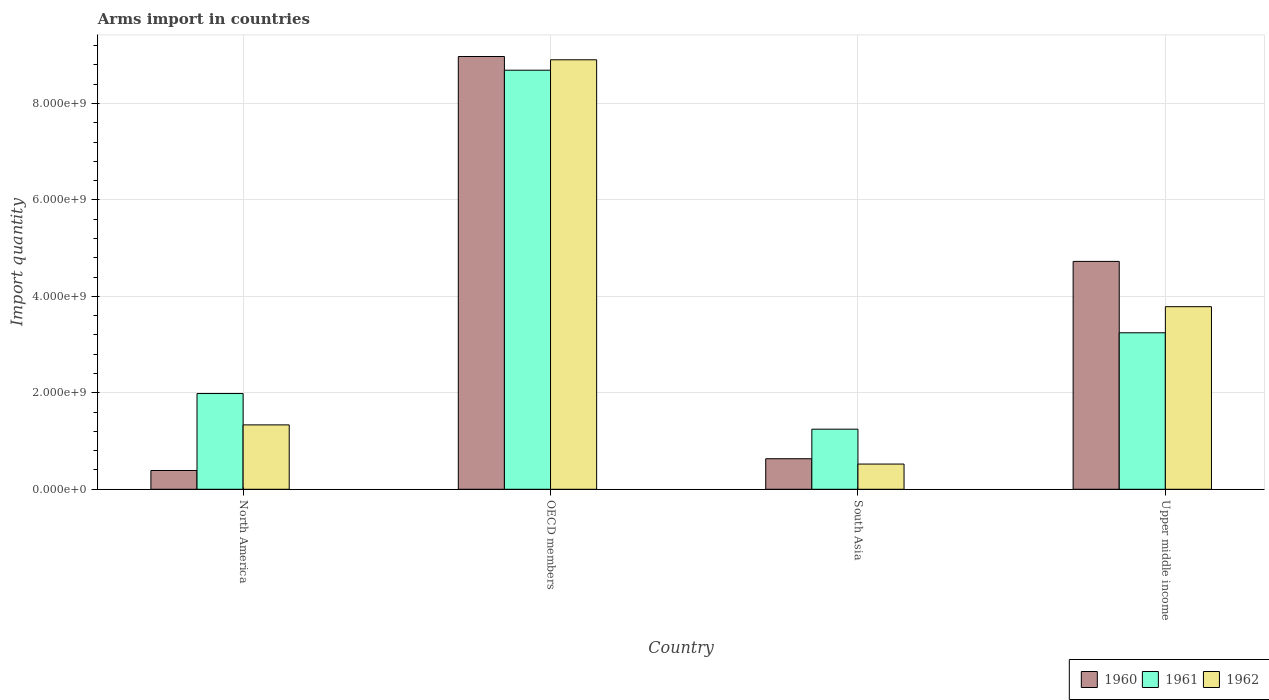How many different coloured bars are there?
Keep it short and to the point. 3. How many groups of bars are there?
Your answer should be compact. 4. Are the number of bars per tick equal to the number of legend labels?
Your response must be concise. Yes. How many bars are there on the 4th tick from the right?
Make the answer very short. 3. What is the total arms import in 1961 in North America?
Ensure brevity in your answer.  1.98e+09. Across all countries, what is the maximum total arms import in 1960?
Offer a terse response. 8.97e+09. Across all countries, what is the minimum total arms import in 1960?
Keep it short and to the point. 3.89e+08. In which country was the total arms import in 1961 maximum?
Offer a terse response. OECD members. In which country was the total arms import in 1962 minimum?
Your answer should be very brief. South Asia. What is the total total arms import in 1962 in the graph?
Offer a terse response. 1.45e+1. What is the difference between the total arms import in 1960 in OECD members and that in South Asia?
Provide a succinct answer. 8.34e+09. What is the difference between the total arms import in 1961 in OECD members and the total arms import in 1962 in Upper middle income?
Keep it short and to the point. 4.90e+09. What is the average total arms import in 1961 per country?
Offer a terse response. 3.79e+09. What is the difference between the total arms import of/in 1960 and total arms import of/in 1961 in Upper middle income?
Offer a terse response. 1.48e+09. In how many countries, is the total arms import in 1961 greater than 4400000000?
Ensure brevity in your answer.  1. What is the ratio of the total arms import in 1961 in North America to that in OECD members?
Your response must be concise. 0.23. Is the total arms import in 1961 in North America less than that in Upper middle income?
Your answer should be compact. Yes. What is the difference between the highest and the second highest total arms import in 1960?
Ensure brevity in your answer.  4.25e+09. What is the difference between the highest and the lowest total arms import in 1962?
Your answer should be compact. 8.38e+09. In how many countries, is the total arms import in 1960 greater than the average total arms import in 1960 taken over all countries?
Provide a short and direct response. 2. Is the sum of the total arms import in 1962 in North America and Upper middle income greater than the maximum total arms import in 1960 across all countries?
Your response must be concise. No. What does the 3rd bar from the left in South Asia represents?
Your response must be concise. 1962. What does the 2nd bar from the right in South Asia represents?
Offer a very short reply. 1961. Is it the case that in every country, the sum of the total arms import in 1962 and total arms import in 1961 is greater than the total arms import in 1960?
Provide a succinct answer. Yes. How many bars are there?
Provide a short and direct response. 12. Are the values on the major ticks of Y-axis written in scientific E-notation?
Provide a succinct answer. Yes. Does the graph contain any zero values?
Ensure brevity in your answer.  No. What is the title of the graph?
Provide a short and direct response. Arms import in countries. What is the label or title of the X-axis?
Provide a short and direct response. Country. What is the label or title of the Y-axis?
Provide a short and direct response. Import quantity. What is the Import quantity of 1960 in North America?
Ensure brevity in your answer.  3.89e+08. What is the Import quantity of 1961 in North America?
Give a very brief answer. 1.98e+09. What is the Import quantity of 1962 in North America?
Offer a very short reply. 1.34e+09. What is the Import quantity in 1960 in OECD members?
Make the answer very short. 8.97e+09. What is the Import quantity of 1961 in OECD members?
Give a very brief answer. 8.69e+09. What is the Import quantity of 1962 in OECD members?
Give a very brief answer. 8.90e+09. What is the Import quantity in 1960 in South Asia?
Provide a succinct answer. 6.33e+08. What is the Import quantity of 1961 in South Asia?
Your response must be concise. 1.25e+09. What is the Import quantity in 1962 in South Asia?
Ensure brevity in your answer.  5.23e+08. What is the Import quantity in 1960 in Upper middle income?
Ensure brevity in your answer.  4.72e+09. What is the Import quantity in 1961 in Upper middle income?
Make the answer very short. 3.24e+09. What is the Import quantity in 1962 in Upper middle income?
Offer a very short reply. 3.79e+09. Across all countries, what is the maximum Import quantity of 1960?
Offer a terse response. 8.97e+09. Across all countries, what is the maximum Import quantity in 1961?
Your answer should be very brief. 8.69e+09. Across all countries, what is the maximum Import quantity in 1962?
Offer a terse response. 8.90e+09. Across all countries, what is the minimum Import quantity of 1960?
Provide a succinct answer. 3.89e+08. Across all countries, what is the minimum Import quantity in 1961?
Keep it short and to the point. 1.25e+09. Across all countries, what is the minimum Import quantity in 1962?
Provide a short and direct response. 5.23e+08. What is the total Import quantity of 1960 in the graph?
Your answer should be compact. 1.47e+1. What is the total Import quantity of 1961 in the graph?
Give a very brief answer. 1.52e+1. What is the total Import quantity of 1962 in the graph?
Ensure brevity in your answer.  1.45e+1. What is the difference between the Import quantity in 1960 in North America and that in OECD members?
Keep it short and to the point. -8.58e+09. What is the difference between the Import quantity in 1961 in North America and that in OECD members?
Provide a succinct answer. -6.70e+09. What is the difference between the Import quantity of 1962 in North America and that in OECD members?
Provide a succinct answer. -7.57e+09. What is the difference between the Import quantity of 1960 in North America and that in South Asia?
Provide a short and direct response. -2.44e+08. What is the difference between the Import quantity in 1961 in North America and that in South Asia?
Keep it short and to the point. 7.39e+08. What is the difference between the Import quantity of 1962 in North America and that in South Asia?
Your answer should be compact. 8.12e+08. What is the difference between the Import quantity in 1960 in North America and that in Upper middle income?
Ensure brevity in your answer.  -4.34e+09. What is the difference between the Import quantity in 1961 in North America and that in Upper middle income?
Ensure brevity in your answer.  -1.26e+09. What is the difference between the Import quantity in 1962 in North America and that in Upper middle income?
Make the answer very short. -2.45e+09. What is the difference between the Import quantity of 1960 in OECD members and that in South Asia?
Make the answer very short. 8.34e+09. What is the difference between the Import quantity of 1961 in OECD members and that in South Asia?
Make the answer very short. 7.44e+09. What is the difference between the Import quantity of 1962 in OECD members and that in South Asia?
Ensure brevity in your answer.  8.38e+09. What is the difference between the Import quantity of 1960 in OECD members and that in Upper middle income?
Offer a very short reply. 4.25e+09. What is the difference between the Import quantity of 1961 in OECD members and that in Upper middle income?
Keep it short and to the point. 5.44e+09. What is the difference between the Import quantity of 1962 in OECD members and that in Upper middle income?
Ensure brevity in your answer.  5.12e+09. What is the difference between the Import quantity of 1960 in South Asia and that in Upper middle income?
Ensure brevity in your answer.  -4.09e+09. What is the difference between the Import quantity of 1961 in South Asia and that in Upper middle income?
Provide a succinct answer. -2.00e+09. What is the difference between the Import quantity in 1962 in South Asia and that in Upper middle income?
Your answer should be compact. -3.26e+09. What is the difference between the Import quantity in 1960 in North America and the Import quantity in 1961 in OECD members?
Offer a very short reply. -8.30e+09. What is the difference between the Import quantity in 1960 in North America and the Import quantity in 1962 in OECD members?
Provide a succinct answer. -8.52e+09. What is the difference between the Import quantity in 1961 in North America and the Import quantity in 1962 in OECD members?
Your answer should be compact. -6.92e+09. What is the difference between the Import quantity of 1960 in North America and the Import quantity of 1961 in South Asia?
Ensure brevity in your answer.  -8.57e+08. What is the difference between the Import quantity in 1960 in North America and the Import quantity in 1962 in South Asia?
Keep it short and to the point. -1.34e+08. What is the difference between the Import quantity of 1961 in North America and the Import quantity of 1962 in South Asia?
Give a very brief answer. 1.46e+09. What is the difference between the Import quantity of 1960 in North America and the Import quantity of 1961 in Upper middle income?
Your answer should be very brief. -2.86e+09. What is the difference between the Import quantity of 1960 in North America and the Import quantity of 1962 in Upper middle income?
Ensure brevity in your answer.  -3.40e+09. What is the difference between the Import quantity in 1961 in North America and the Import quantity in 1962 in Upper middle income?
Give a very brief answer. -1.80e+09. What is the difference between the Import quantity of 1960 in OECD members and the Import quantity of 1961 in South Asia?
Your answer should be very brief. 7.73e+09. What is the difference between the Import quantity in 1960 in OECD members and the Import quantity in 1962 in South Asia?
Your response must be concise. 8.45e+09. What is the difference between the Import quantity of 1961 in OECD members and the Import quantity of 1962 in South Asia?
Make the answer very short. 8.17e+09. What is the difference between the Import quantity in 1960 in OECD members and the Import quantity in 1961 in Upper middle income?
Keep it short and to the point. 5.73e+09. What is the difference between the Import quantity in 1960 in OECD members and the Import quantity in 1962 in Upper middle income?
Your answer should be compact. 5.19e+09. What is the difference between the Import quantity in 1961 in OECD members and the Import quantity in 1962 in Upper middle income?
Your response must be concise. 4.90e+09. What is the difference between the Import quantity of 1960 in South Asia and the Import quantity of 1961 in Upper middle income?
Keep it short and to the point. -2.61e+09. What is the difference between the Import quantity in 1960 in South Asia and the Import quantity in 1962 in Upper middle income?
Your response must be concise. -3.15e+09. What is the difference between the Import quantity of 1961 in South Asia and the Import quantity of 1962 in Upper middle income?
Give a very brief answer. -2.54e+09. What is the average Import quantity in 1960 per country?
Your response must be concise. 3.68e+09. What is the average Import quantity of 1961 per country?
Keep it short and to the point. 3.79e+09. What is the average Import quantity of 1962 per country?
Your answer should be compact. 3.64e+09. What is the difference between the Import quantity of 1960 and Import quantity of 1961 in North America?
Keep it short and to the point. -1.60e+09. What is the difference between the Import quantity of 1960 and Import quantity of 1962 in North America?
Offer a very short reply. -9.46e+08. What is the difference between the Import quantity in 1961 and Import quantity in 1962 in North America?
Provide a short and direct response. 6.50e+08. What is the difference between the Import quantity of 1960 and Import quantity of 1961 in OECD members?
Keep it short and to the point. 2.84e+08. What is the difference between the Import quantity in 1960 and Import quantity in 1962 in OECD members?
Provide a short and direct response. 6.80e+07. What is the difference between the Import quantity of 1961 and Import quantity of 1962 in OECD members?
Your response must be concise. -2.16e+08. What is the difference between the Import quantity of 1960 and Import quantity of 1961 in South Asia?
Offer a very short reply. -6.13e+08. What is the difference between the Import quantity of 1960 and Import quantity of 1962 in South Asia?
Your answer should be compact. 1.10e+08. What is the difference between the Import quantity of 1961 and Import quantity of 1962 in South Asia?
Provide a succinct answer. 7.23e+08. What is the difference between the Import quantity in 1960 and Import quantity in 1961 in Upper middle income?
Offer a terse response. 1.48e+09. What is the difference between the Import quantity of 1960 and Import quantity of 1962 in Upper middle income?
Offer a very short reply. 9.39e+08. What is the difference between the Import quantity of 1961 and Import quantity of 1962 in Upper middle income?
Make the answer very short. -5.41e+08. What is the ratio of the Import quantity of 1960 in North America to that in OECD members?
Offer a terse response. 0.04. What is the ratio of the Import quantity of 1961 in North America to that in OECD members?
Your answer should be very brief. 0.23. What is the ratio of the Import quantity in 1962 in North America to that in OECD members?
Offer a terse response. 0.15. What is the ratio of the Import quantity in 1960 in North America to that in South Asia?
Keep it short and to the point. 0.61. What is the ratio of the Import quantity in 1961 in North America to that in South Asia?
Provide a succinct answer. 1.59. What is the ratio of the Import quantity in 1962 in North America to that in South Asia?
Provide a succinct answer. 2.55. What is the ratio of the Import quantity of 1960 in North America to that in Upper middle income?
Make the answer very short. 0.08. What is the ratio of the Import quantity in 1961 in North America to that in Upper middle income?
Your answer should be very brief. 0.61. What is the ratio of the Import quantity of 1962 in North America to that in Upper middle income?
Your response must be concise. 0.35. What is the ratio of the Import quantity of 1960 in OECD members to that in South Asia?
Ensure brevity in your answer.  14.18. What is the ratio of the Import quantity of 1961 in OECD members to that in South Asia?
Make the answer very short. 6.97. What is the ratio of the Import quantity of 1962 in OECD members to that in South Asia?
Provide a succinct answer. 17.03. What is the ratio of the Import quantity of 1960 in OECD members to that in Upper middle income?
Provide a succinct answer. 1.9. What is the ratio of the Import quantity in 1961 in OECD members to that in Upper middle income?
Offer a very short reply. 2.68. What is the ratio of the Import quantity in 1962 in OECD members to that in Upper middle income?
Your answer should be very brief. 2.35. What is the ratio of the Import quantity in 1960 in South Asia to that in Upper middle income?
Keep it short and to the point. 0.13. What is the ratio of the Import quantity in 1961 in South Asia to that in Upper middle income?
Your answer should be very brief. 0.38. What is the ratio of the Import quantity of 1962 in South Asia to that in Upper middle income?
Ensure brevity in your answer.  0.14. What is the difference between the highest and the second highest Import quantity in 1960?
Provide a succinct answer. 4.25e+09. What is the difference between the highest and the second highest Import quantity in 1961?
Make the answer very short. 5.44e+09. What is the difference between the highest and the second highest Import quantity in 1962?
Provide a succinct answer. 5.12e+09. What is the difference between the highest and the lowest Import quantity of 1960?
Your answer should be compact. 8.58e+09. What is the difference between the highest and the lowest Import quantity in 1961?
Your answer should be compact. 7.44e+09. What is the difference between the highest and the lowest Import quantity in 1962?
Make the answer very short. 8.38e+09. 